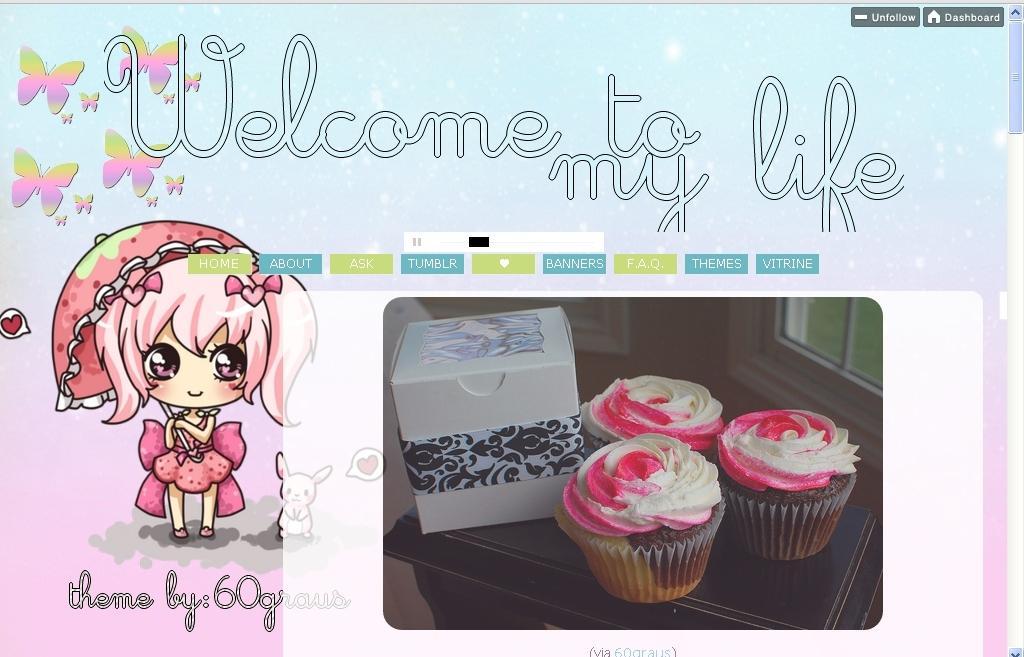How would you summarize this image in a sentence or two? It is an edited image. In this image there is a depiction of a doll. There are cupcakes and an object on the table. There is a glass window. There is some text on the image. 